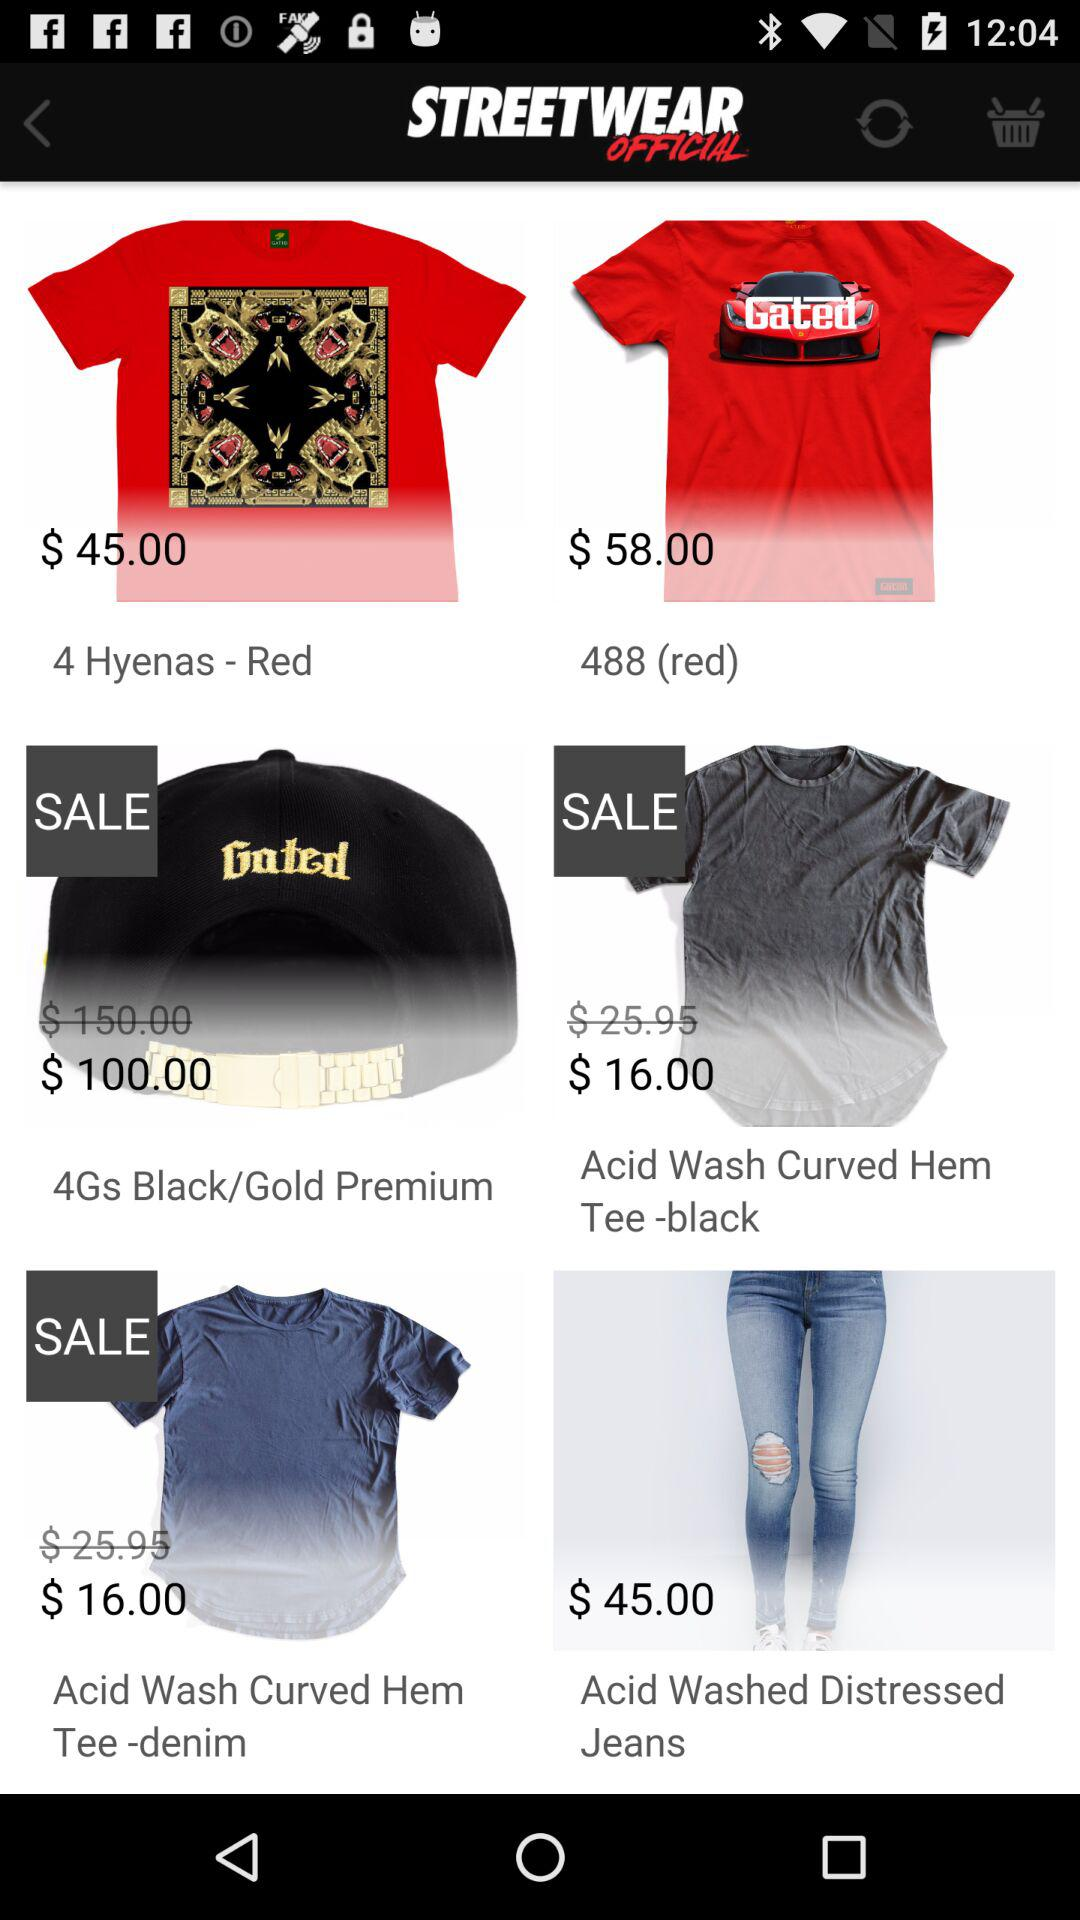What is the price of "Acid Wash Curved Hem Tee -black" before sale? The price before sale is $25.95. 